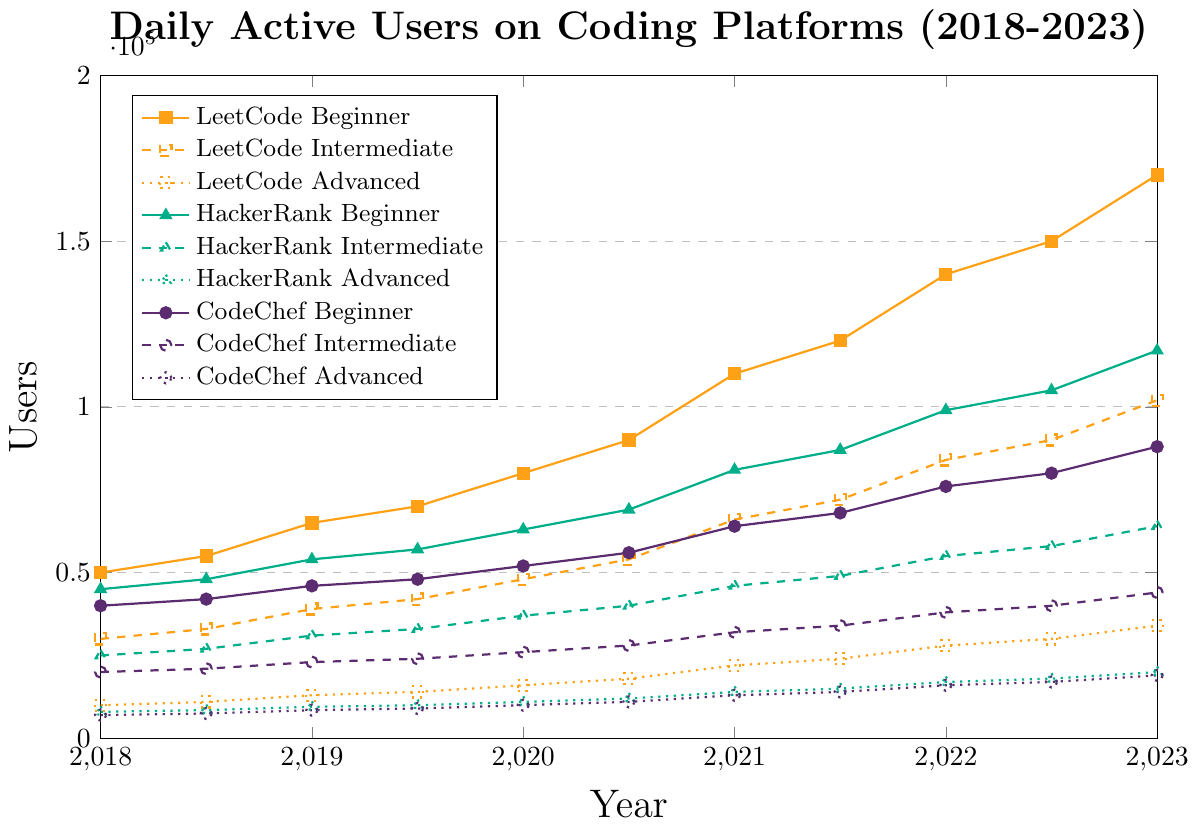What is the total number of daily active users for LeetCode across all skill levels in 2020? Sum the counts for LeetCode Beginner (90000), Intermediate (54000), and Advanced (18000). So, 90000 + 54000 + 18000 = 162000.
Answer: 162,000 Which platform had the highest number of daily active users for beginners in 2022? Compare the beginners' numbers for all platforms in 2022: LeetCode (140000), HackerRank (99000), and CodeChef (76000). LeetCode has the highest number.
Answer: LeetCode Which skill level saw the most significant increase in daily active users on HackerRank between 2018 and 2023? Compare the increase of users from 2018 to 2023 for each level on HackerRank: Beginner (123000-45000=78000), Intermediate (67000-25000=42000), Advanced (21000-8000=13000). The Beginner level saw the most significant increase.
Answer: Beginner What is the difference in daily active users between HackerRank Intermediate and CodeChef Advanced in December 2021? Subtract the count of CodeChef Advanced (15000) from HackerRank Intermediate (52000) in December 2021. So, 52000 - 15000 = 37000.
Answer: 37000 Which platform's advanced users reached exactly 20000 first, and in which month? Check the timeline for the advanced user count reaching 20000: LeetCode (January 2020), HackerRank (June 2023), CodeChef (June 2020). LeetCode reached this number first in January 2020.
Answer: LeetCode, January 2020 